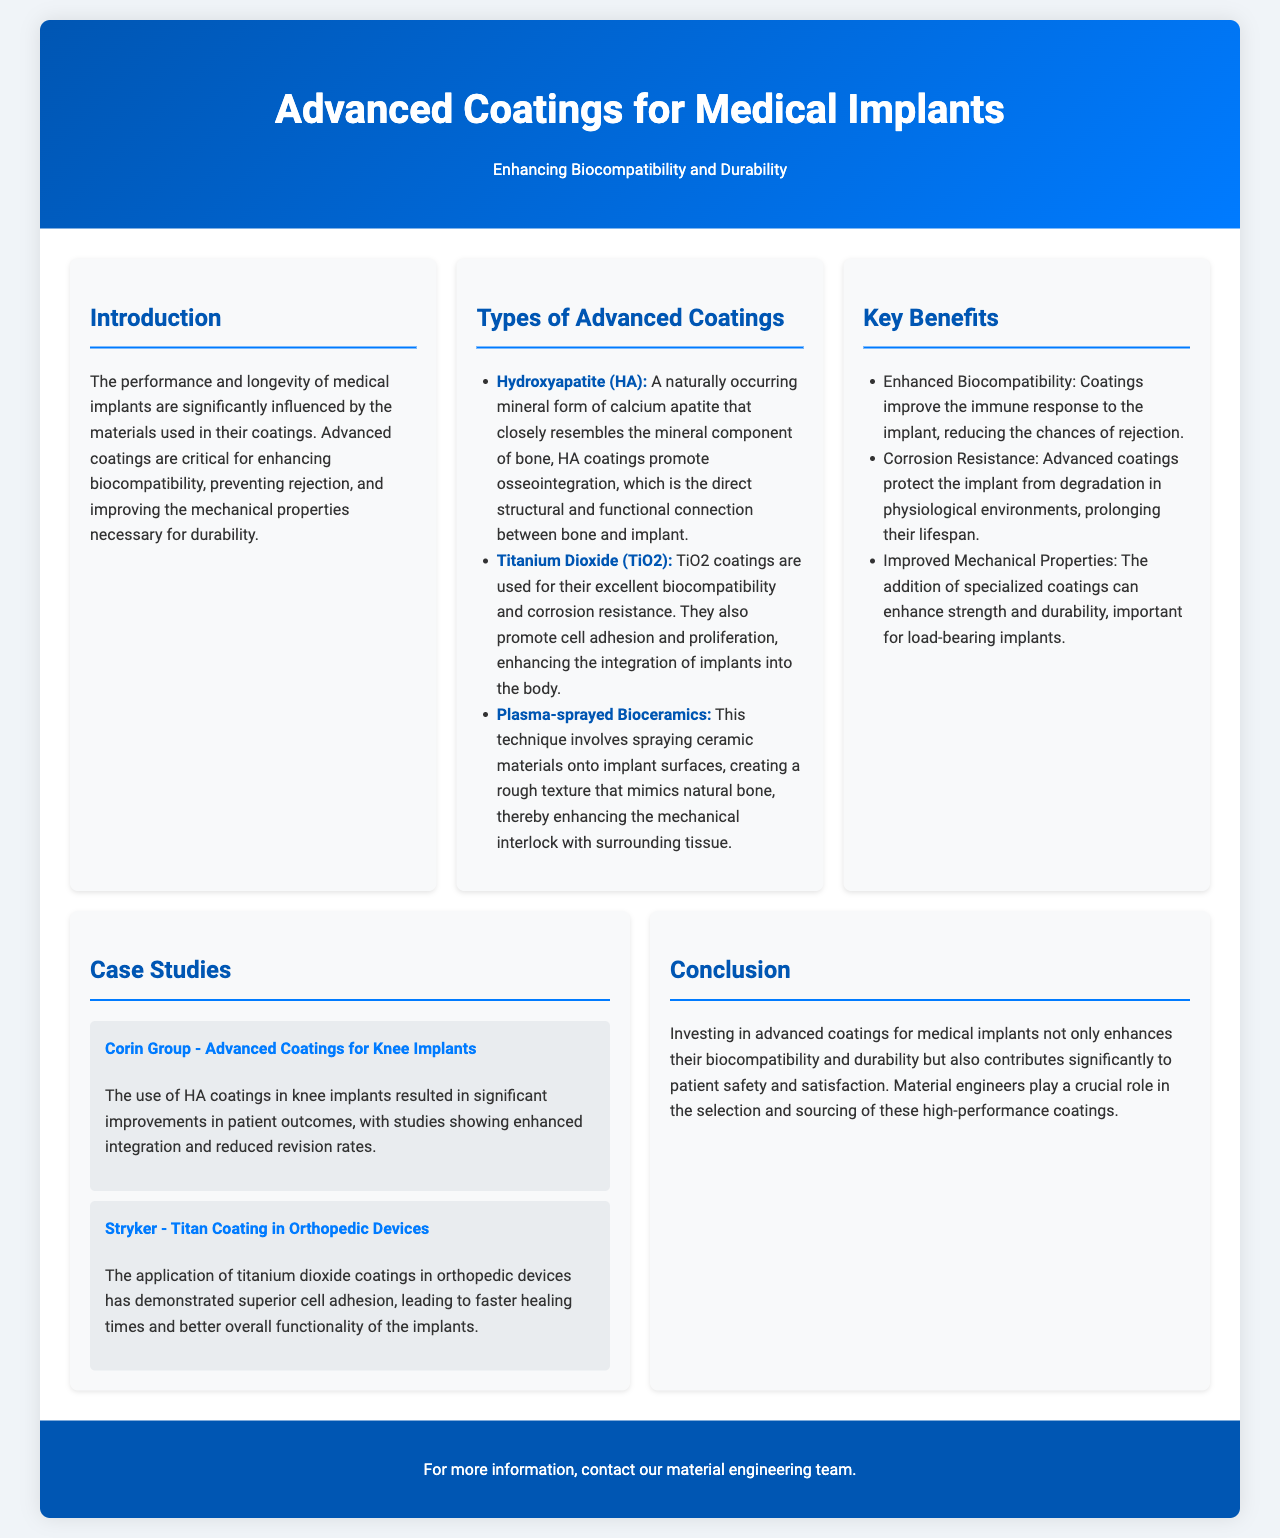What are the two main focuses of the brochure? The brochure emphasizes enhancing biocompatibility and durability of medical implants.
Answer: Biocompatibility and durability What is one type of advanced coating mentioned? The document lists Hydroxyapatite, Titanium Dioxide, and Plasma-sprayed Bioceramics as advanced coatings.
Answer: Hydroxyapatite What benefit do coatings provide to implants regarding rejection? The coatings improve the immune response to the implant, reducing the chances of rejection.
Answer: Reducing rejection Which company is associated with advanced coatings for knee implants? The case study mentions Corin Group in context with advanced coatings for knee implants.
Answer: Corin Group What was shown to be enhanced by HA coatings in knee implants? The document indicates that HA coatings resulted in significant improvements in patient outcomes and enhanced integration.
Answer: Patient outcomes How do titanium dioxide coatings benefit orthopedic devices? The document states that titanium dioxide coatings lead to superior cell adhesion, which contributes to faster healing times.
Answer: Faster healing times What is the primary purpose of advanced coatings for medical implants? The primary purpose is to enhance biocompatibility and durability.
Answer: Enhance biocompatibility and durability How does the brochure suggest that advanced coatings impact patient safety? The brochure concludes that investing in advanced coatings contributes significantly to patient safety and satisfaction.
Answer: Patient safety What technique involves spraying ceramic materials onto implant surfaces? The document describes "Plasma-sprayed Bioceramics" as the technique used.
Answer: Plasma-sprayed Bioceramics 